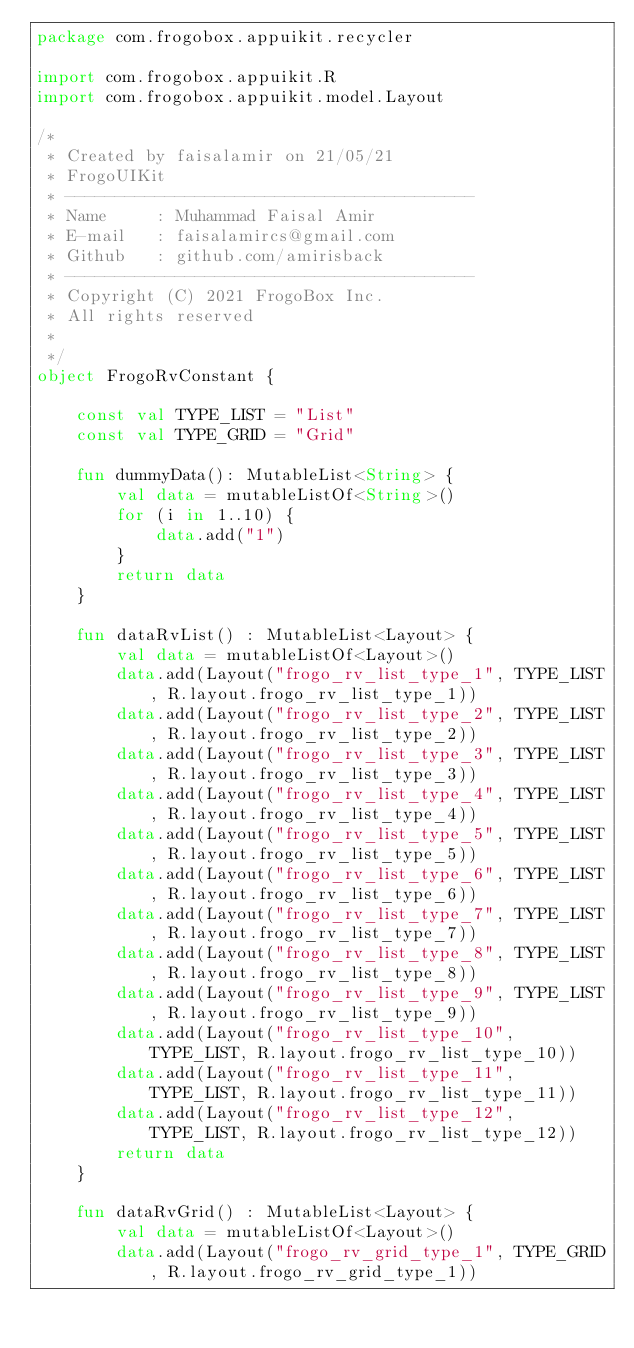<code> <loc_0><loc_0><loc_500><loc_500><_Kotlin_>package com.frogobox.appuikit.recycler

import com.frogobox.appuikit.R
import com.frogobox.appuikit.model.Layout

/*
 * Created by faisalamir on 21/05/21
 * FrogoUIKit
 * -----------------------------------------
 * Name     : Muhammad Faisal Amir
 * E-mail   : faisalamircs@gmail.com
 * Github   : github.com/amirisback
 * -----------------------------------------
 * Copyright (C) 2021 FrogoBox Inc.      
 * All rights reserved
 *
 */
object FrogoRvConstant {
    
    const val TYPE_LIST = "List"
    const val TYPE_GRID = "Grid"

    fun dummyData(): MutableList<String> {
        val data = mutableListOf<String>()
        for (i in 1..10) {
            data.add("1")
        }
        return data
    }
    
    fun dataRvList() : MutableList<Layout> {
        val data = mutableListOf<Layout>()
        data.add(Layout("frogo_rv_list_type_1", TYPE_LIST, R.layout.frogo_rv_list_type_1))
        data.add(Layout("frogo_rv_list_type_2", TYPE_LIST, R.layout.frogo_rv_list_type_2))
        data.add(Layout("frogo_rv_list_type_3", TYPE_LIST, R.layout.frogo_rv_list_type_3))
        data.add(Layout("frogo_rv_list_type_4", TYPE_LIST, R.layout.frogo_rv_list_type_4))
        data.add(Layout("frogo_rv_list_type_5", TYPE_LIST, R.layout.frogo_rv_list_type_5))
        data.add(Layout("frogo_rv_list_type_6", TYPE_LIST, R.layout.frogo_rv_list_type_6))
        data.add(Layout("frogo_rv_list_type_7", TYPE_LIST, R.layout.frogo_rv_list_type_7))
        data.add(Layout("frogo_rv_list_type_8", TYPE_LIST, R.layout.frogo_rv_list_type_8))
        data.add(Layout("frogo_rv_list_type_9", TYPE_LIST, R.layout.frogo_rv_list_type_9))
        data.add(Layout("frogo_rv_list_type_10", TYPE_LIST, R.layout.frogo_rv_list_type_10))
        data.add(Layout("frogo_rv_list_type_11", TYPE_LIST, R.layout.frogo_rv_list_type_11))
        data.add(Layout("frogo_rv_list_type_12", TYPE_LIST, R.layout.frogo_rv_list_type_12))
        return data
    }

    fun dataRvGrid() : MutableList<Layout> {
        val data = mutableListOf<Layout>()
        data.add(Layout("frogo_rv_grid_type_1", TYPE_GRID, R.layout.frogo_rv_grid_type_1))</code> 